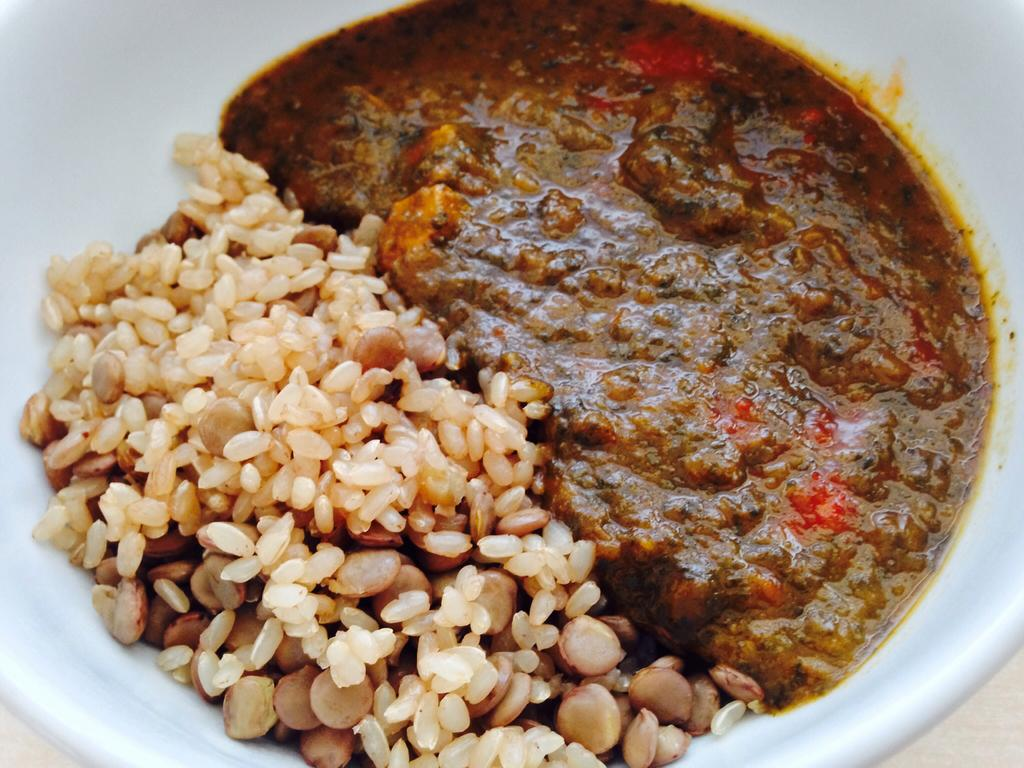What is present on the plate in the image? There is food on a plate in the image. What type of book is placed on the plate in the image? There is no book present on the plate in the image; it only contains food. 